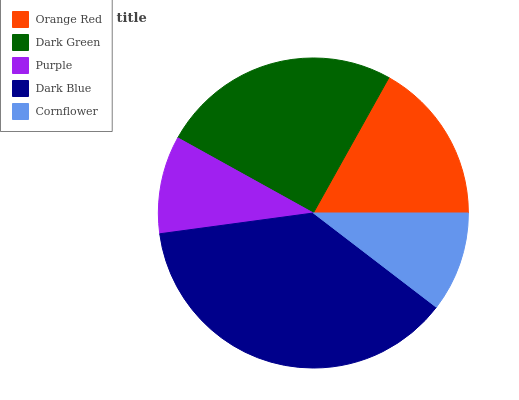Is Purple the minimum?
Answer yes or no. Yes. Is Dark Blue the maximum?
Answer yes or no. Yes. Is Dark Green the minimum?
Answer yes or no. No. Is Dark Green the maximum?
Answer yes or no. No. Is Dark Green greater than Orange Red?
Answer yes or no. Yes. Is Orange Red less than Dark Green?
Answer yes or no. Yes. Is Orange Red greater than Dark Green?
Answer yes or no. No. Is Dark Green less than Orange Red?
Answer yes or no. No. Is Orange Red the high median?
Answer yes or no. Yes. Is Orange Red the low median?
Answer yes or no. Yes. Is Dark Blue the high median?
Answer yes or no. No. Is Purple the low median?
Answer yes or no. No. 